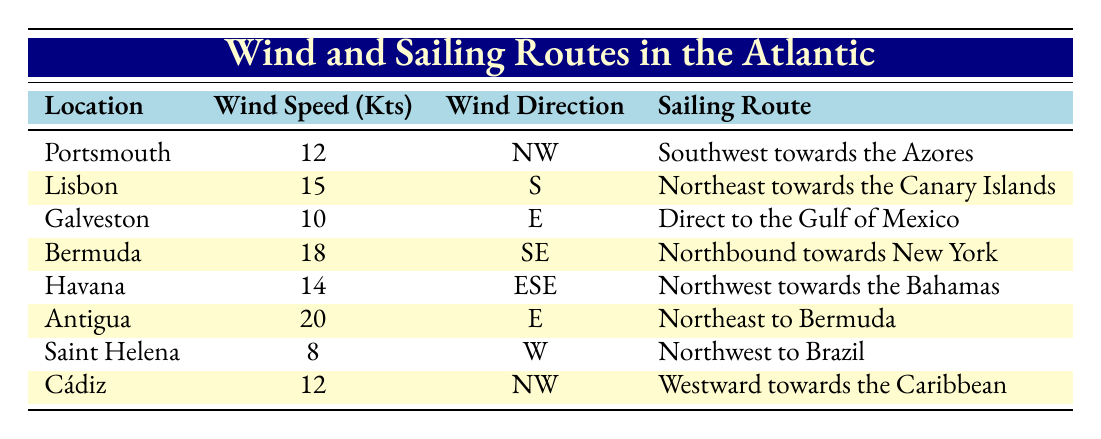What is the average wind speed at Antigua? The wind speed at Antigua is 20 knots. Since we only need the value of wind speed from one specific location, the average is simply the value given for that location.
Answer: 20 Which location has the highest average wind speed? From the table, the wind speeds listed are: Portsmouth 12, Lisbon 15, Galveston 10, Bermuda 18, Havana 14, Antigua 20, Saint Helena 8, and Cádiz 12. The highest among these is 20 knots at Antigua.
Answer: Antigua Is the prevailing wind direction at Lisbon south? The table shows the prevailing wind direction at Lisbon is "S." Therefore, the statement is true.
Answer: Yes What sailing route does the prevailing wind direction of east suggest for Antigua? The table indicates that the average wind speed at Antigua is 20 knots with an east prevailing wind direction. It also states that the sailing route is "Northeast to Bermuda," which is consistent with that direction.
Answer: Northeast to Bermuda If we sum the average wind speeds of Portsmouth, Cádiz, and Havana, what do we get? Portsmouth has 12 knots, Cádiz has 12 knots, and Havana has 14 knots. Summing these values gives us 12 + 12 + 14 = 38 knots.
Answer: 38 Which two locations have the same prevailing wind direction as each other? The table shows that Portsmouth and Cádiz both have a prevailing wind direction of "NW." Therefore, they share the same direction.
Answer: Portsmouth and Cádiz What is the sailing route from Saint Helena based on its prevailing wind direction? The table provides that the prevailing wind direction at Saint Helena is "W." The corresponding sailing route is "Northwest to Brazil." Hence, the sailing route reflects this direction.
Answer: Northwest to Brazil Are there any locations with an average wind speed of less than 10 knots? Upon reviewing the table, the data shows that the lowest wind speed is 8 knots at Saint Helena. Since 8 is less than 10, the answer is true.
Answer: No 